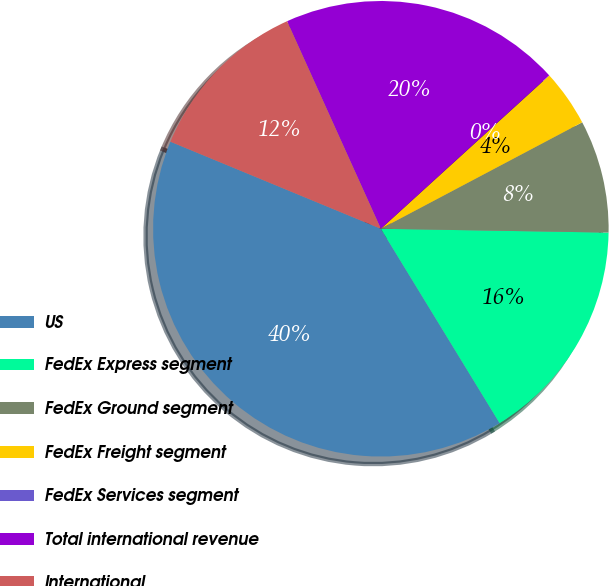Convert chart to OTSL. <chart><loc_0><loc_0><loc_500><loc_500><pie_chart><fcel>US<fcel>FedEx Express segment<fcel>FedEx Ground segment<fcel>FedEx Freight segment<fcel>FedEx Services segment<fcel>Total international revenue<fcel>International<nl><fcel>39.97%<fcel>16.0%<fcel>8.01%<fcel>4.01%<fcel>0.01%<fcel>19.99%<fcel>12.0%<nl></chart> 